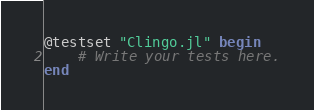Convert code to text. <code><loc_0><loc_0><loc_500><loc_500><_Julia_>
@testset "Clingo.jl" begin
    # Write your tests here.
end
</code> 